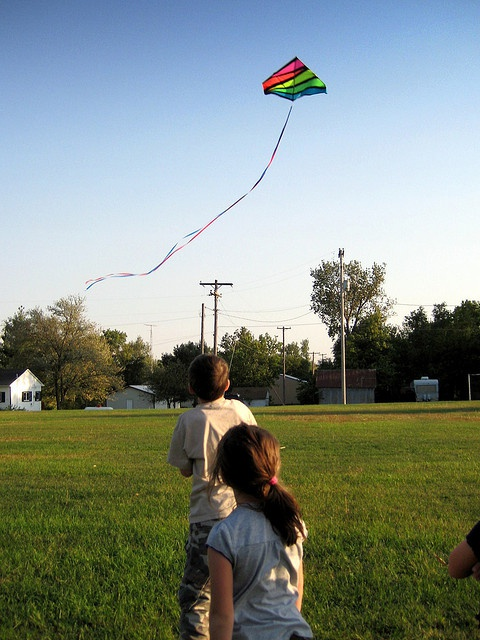Describe the objects in this image and their specific colors. I can see people in gray, black, maroon, and olive tones, people in gray, black, tan, and darkgreen tones, kite in gray, black, green, blue, and darkgreen tones, and people in gray, black, maroon, olive, and darkgreen tones in this image. 